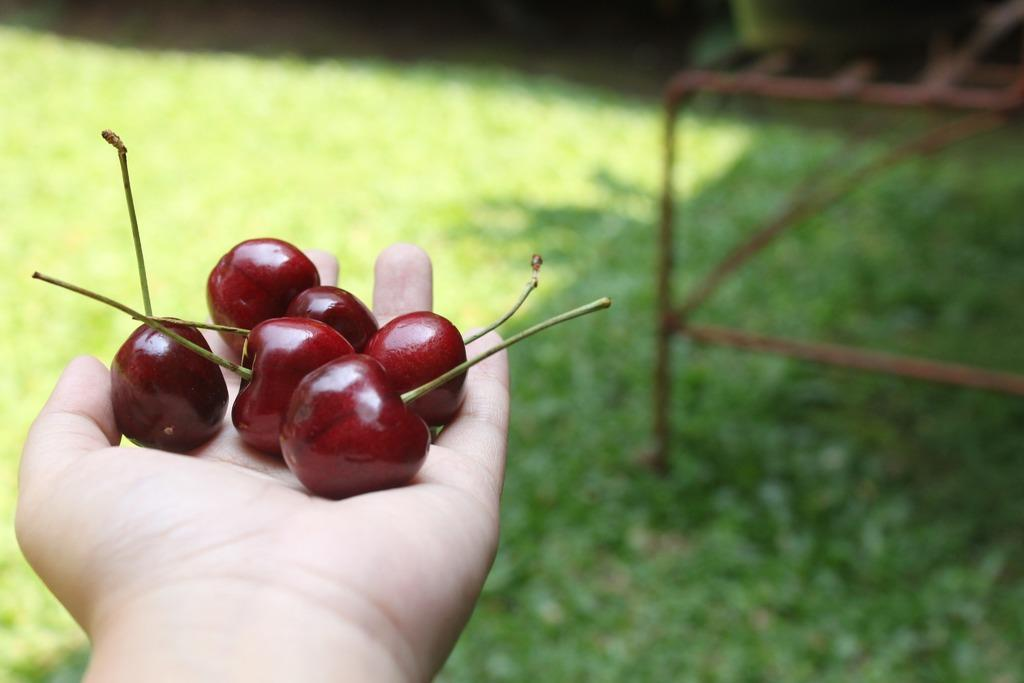What is the person holding in the image? There is a person's hand holding berries in the image. What type of vegetation can be seen at the bottom of the image? There is grass visible at the bottom of the image. What type of stamp can be seen on the person's suit in the image? There is no suit or stamp present in the image; it only shows a person's hand holding berries and grass at the bottom. 